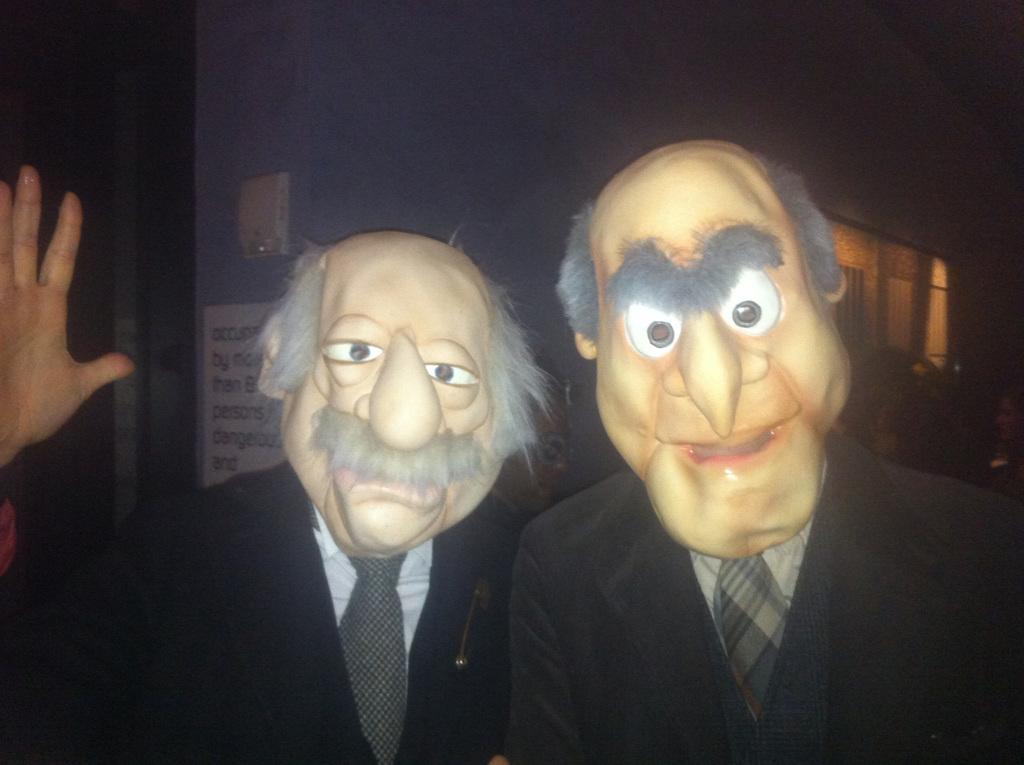In one or two sentences, can you explain what this image depicts? In this image there are two persons who wore two masks. In the background there is a wall on which there is a label. 